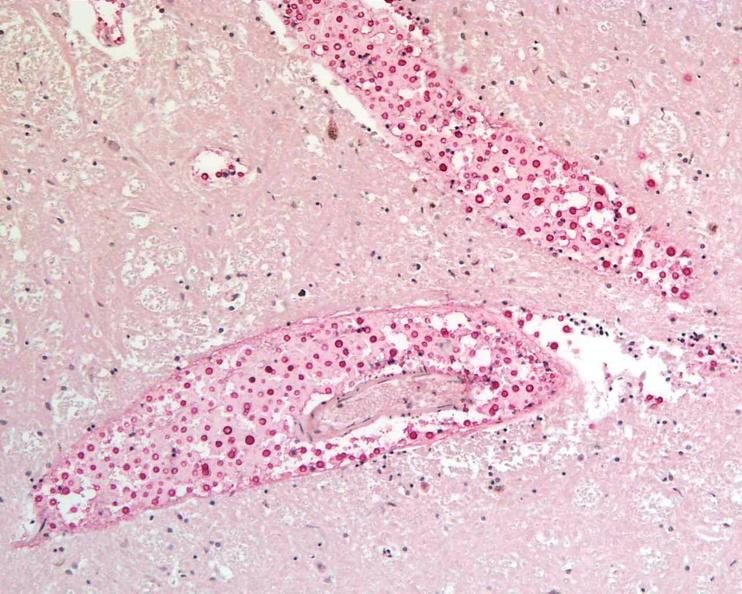does this image show brain, cryptococcal meningitis?
Answer the question using a single word or phrase. Yes 